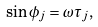Convert formula to latex. <formula><loc_0><loc_0><loc_500><loc_500>\sin \phi _ { j } = \omega \tau _ { j } ,</formula> 